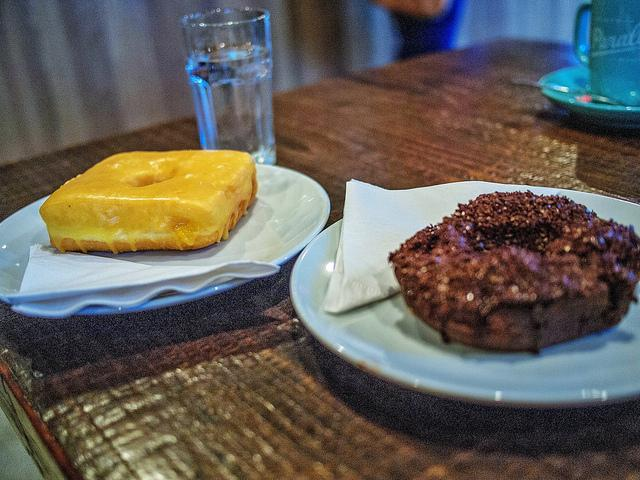What material would the plates be made of? ceramic 